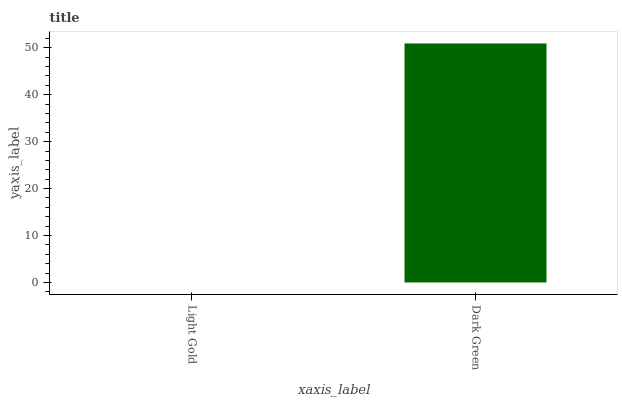Is Light Gold the minimum?
Answer yes or no. Yes. Is Dark Green the maximum?
Answer yes or no. Yes. Is Dark Green the minimum?
Answer yes or no. No. Is Dark Green greater than Light Gold?
Answer yes or no. Yes. Is Light Gold less than Dark Green?
Answer yes or no. Yes. Is Light Gold greater than Dark Green?
Answer yes or no. No. Is Dark Green less than Light Gold?
Answer yes or no. No. Is Dark Green the high median?
Answer yes or no. Yes. Is Light Gold the low median?
Answer yes or no. Yes. Is Light Gold the high median?
Answer yes or no. No. Is Dark Green the low median?
Answer yes or no. No. 